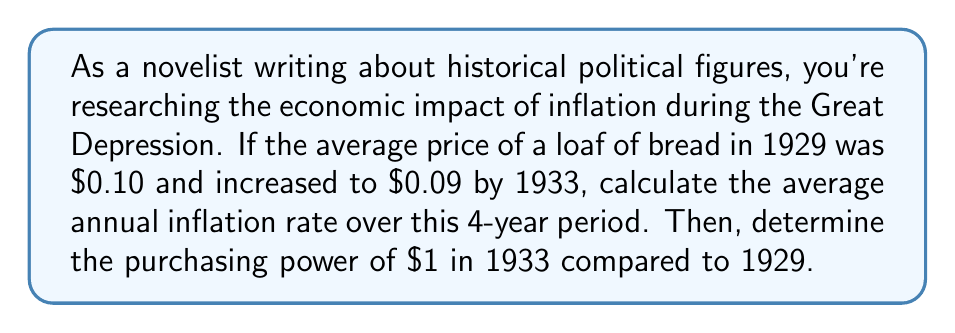Teach me how to tackle this problem. To solve this problem, we'll use the following steps:

1. Calculate the total inflation rate from 1929 to 1933
2. Convert the total inflation rate to an average annual rate
3. Calculate the purchasing power of $1 in 1933 compared to 1929

Step 1: Calculate the total inflation rate
The inflation rate is the percentage change in prices over time. We can calculate it using the formula:

$$ \text{Inflation Rate} = \frac{\text{New Price} - \text{Original Price}}{\text{Original Price}} \times 100\% $$

$$ \text{Inflation Rate} = \frac{0.09 - 0.10}{0.10} \times 100\% = -10\% $$

This negative value indicates deflation rather than inflation.

Step 2: Convert to average annual rate
To find the average annual rate, we use the compound annual growth rate (CAGR) formula:

$$ (1 + r)^n = \frac{\text{End Value}}{\text{Start Value}} $$

Where $r$ is the annual rate, and $n$ is the number of years.

$$ (1 + r)^4 = \frac{0.09}{0.10} $$
$$ (1 + r)^4 = 0.9 $$
$$ 1 + r = 0.9^{\frac{1}{4}} $$
$$ r = 0.9^{\frac{1}{4}} - 1 \approx -0.0256 \text{ or } -2.56\% $$

Step 3: Calculate purchasing power
The purchasing power of $1 in 1933 compared to 1929 can be calculated as:

$$ \text{Purchasing Power} = \frac{1}{\text{Cumulative Inflation Rate}} $$

$$ \text{Purchasing Power} = \frac{1}{0.9} \approx 1.1111 $$

This means $1 in 1933 could buy approximately 11.11% more goods than $1 in 1929.
Answer: The average annual inflation rate from 1929 to 1933 was approximately -2.56% (deflation). The purchasing power of $1 in 1933 was about 1.1111 times that of $1 in 1929, meaning it could buy 11.11% more goods. 